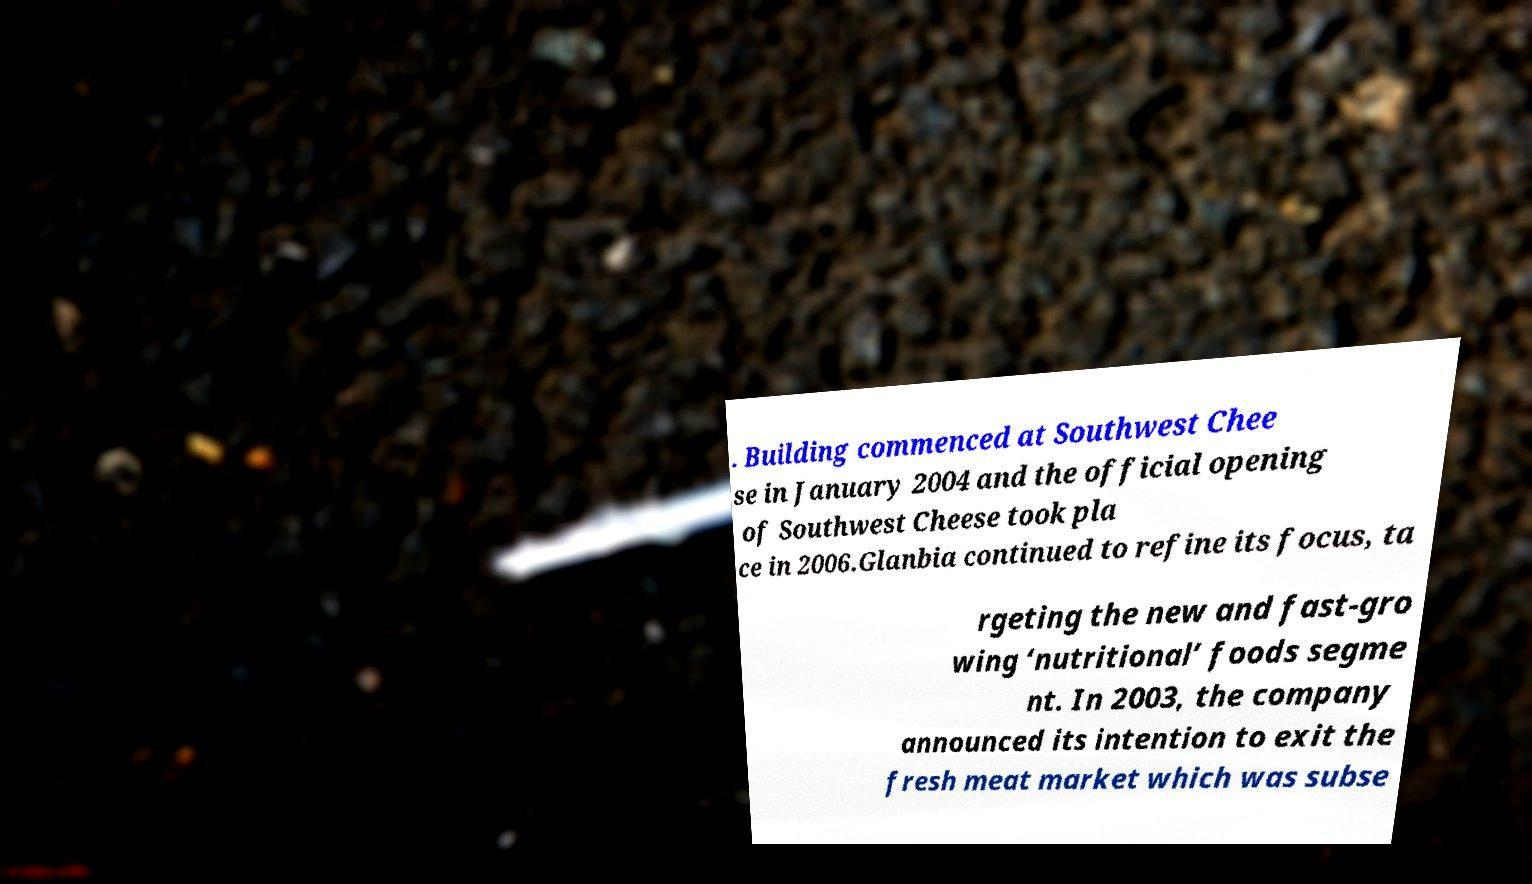There's text embedded in this image that I need extracted. Can you transcribe it verbatim? . Building commenced at Southwest Chee se in January 2004 and the official opening of Southwest Cheese took pla ce in 2006.Glanbia continued to refine its focus, ta rgeting the new and fast-gro wing ‘nutritional’ foods segme nt. In 2003, the company announced its intention to exit the fresh meat market which was subse 